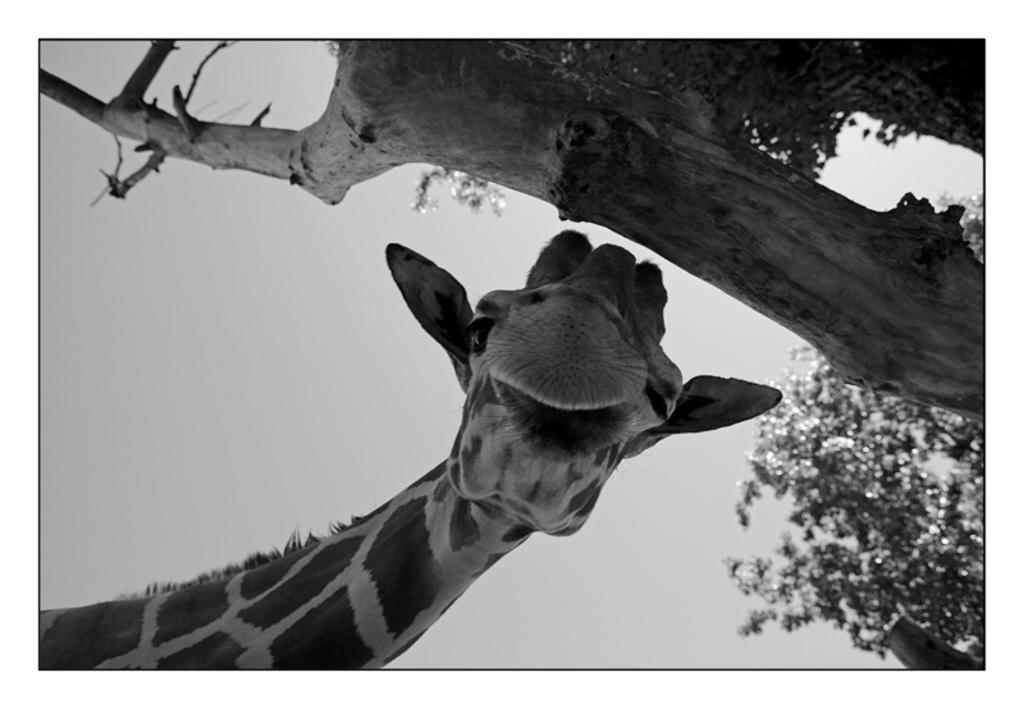What is the color scheme of the image? The image is black and white. What animal can be seen in the image? There is a giraffe in the image. What type of plant is present in the image? There is a tree in the image. Can you describe the branch of the tree in the image? There is a branch of a tree on the right side of the image. What type of wood is the tramp made of in the image? There is no tramp present in the image, so it is not possible to determine what type of wood it might be made of. 